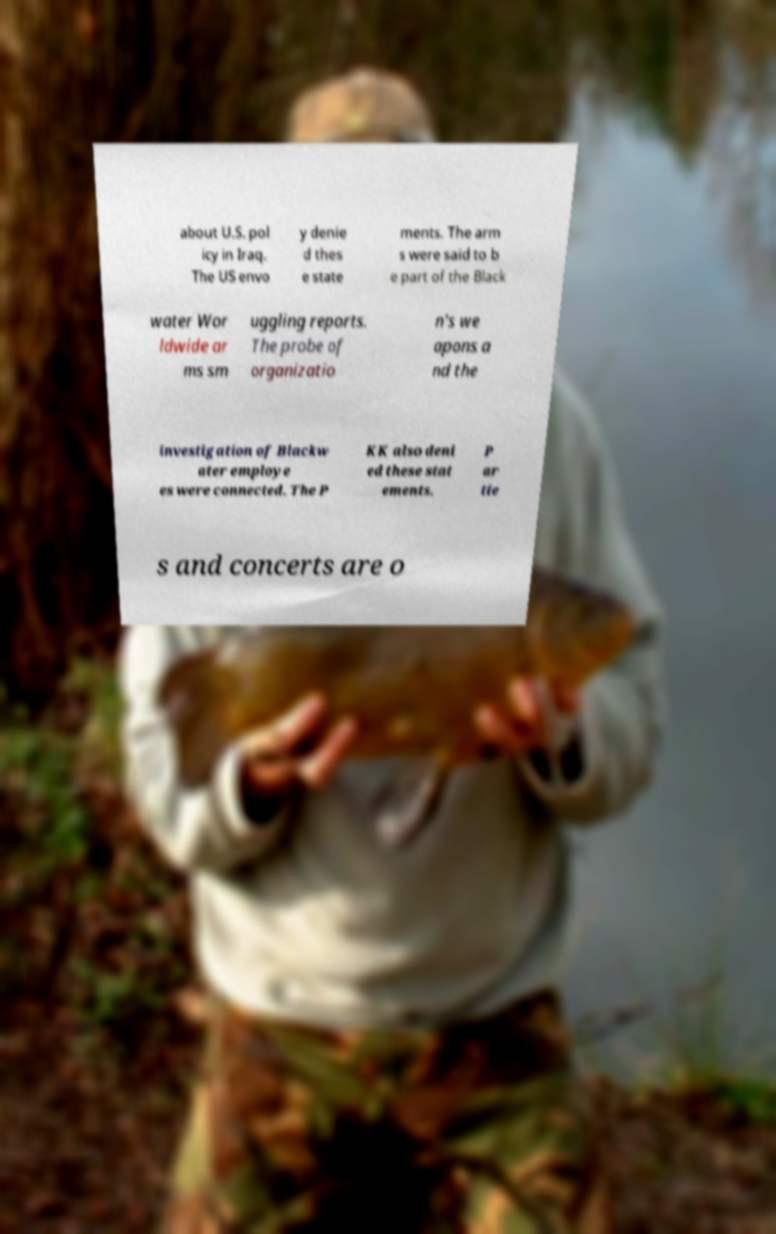Could you assist in decoding the text presented in this image and type it out clearly? about U.S. pol icy in Iraq. The US envo y denie d thes e state ments. The arm s were said to b e part of the Black water Wor ldwide ar ms sm uggling reports. The probe of organizatio n's we apons a nd the investigation of Blackw ater employe es were connected. The P KK also deni ed these stat ements. P ar tie s and concerts are o 